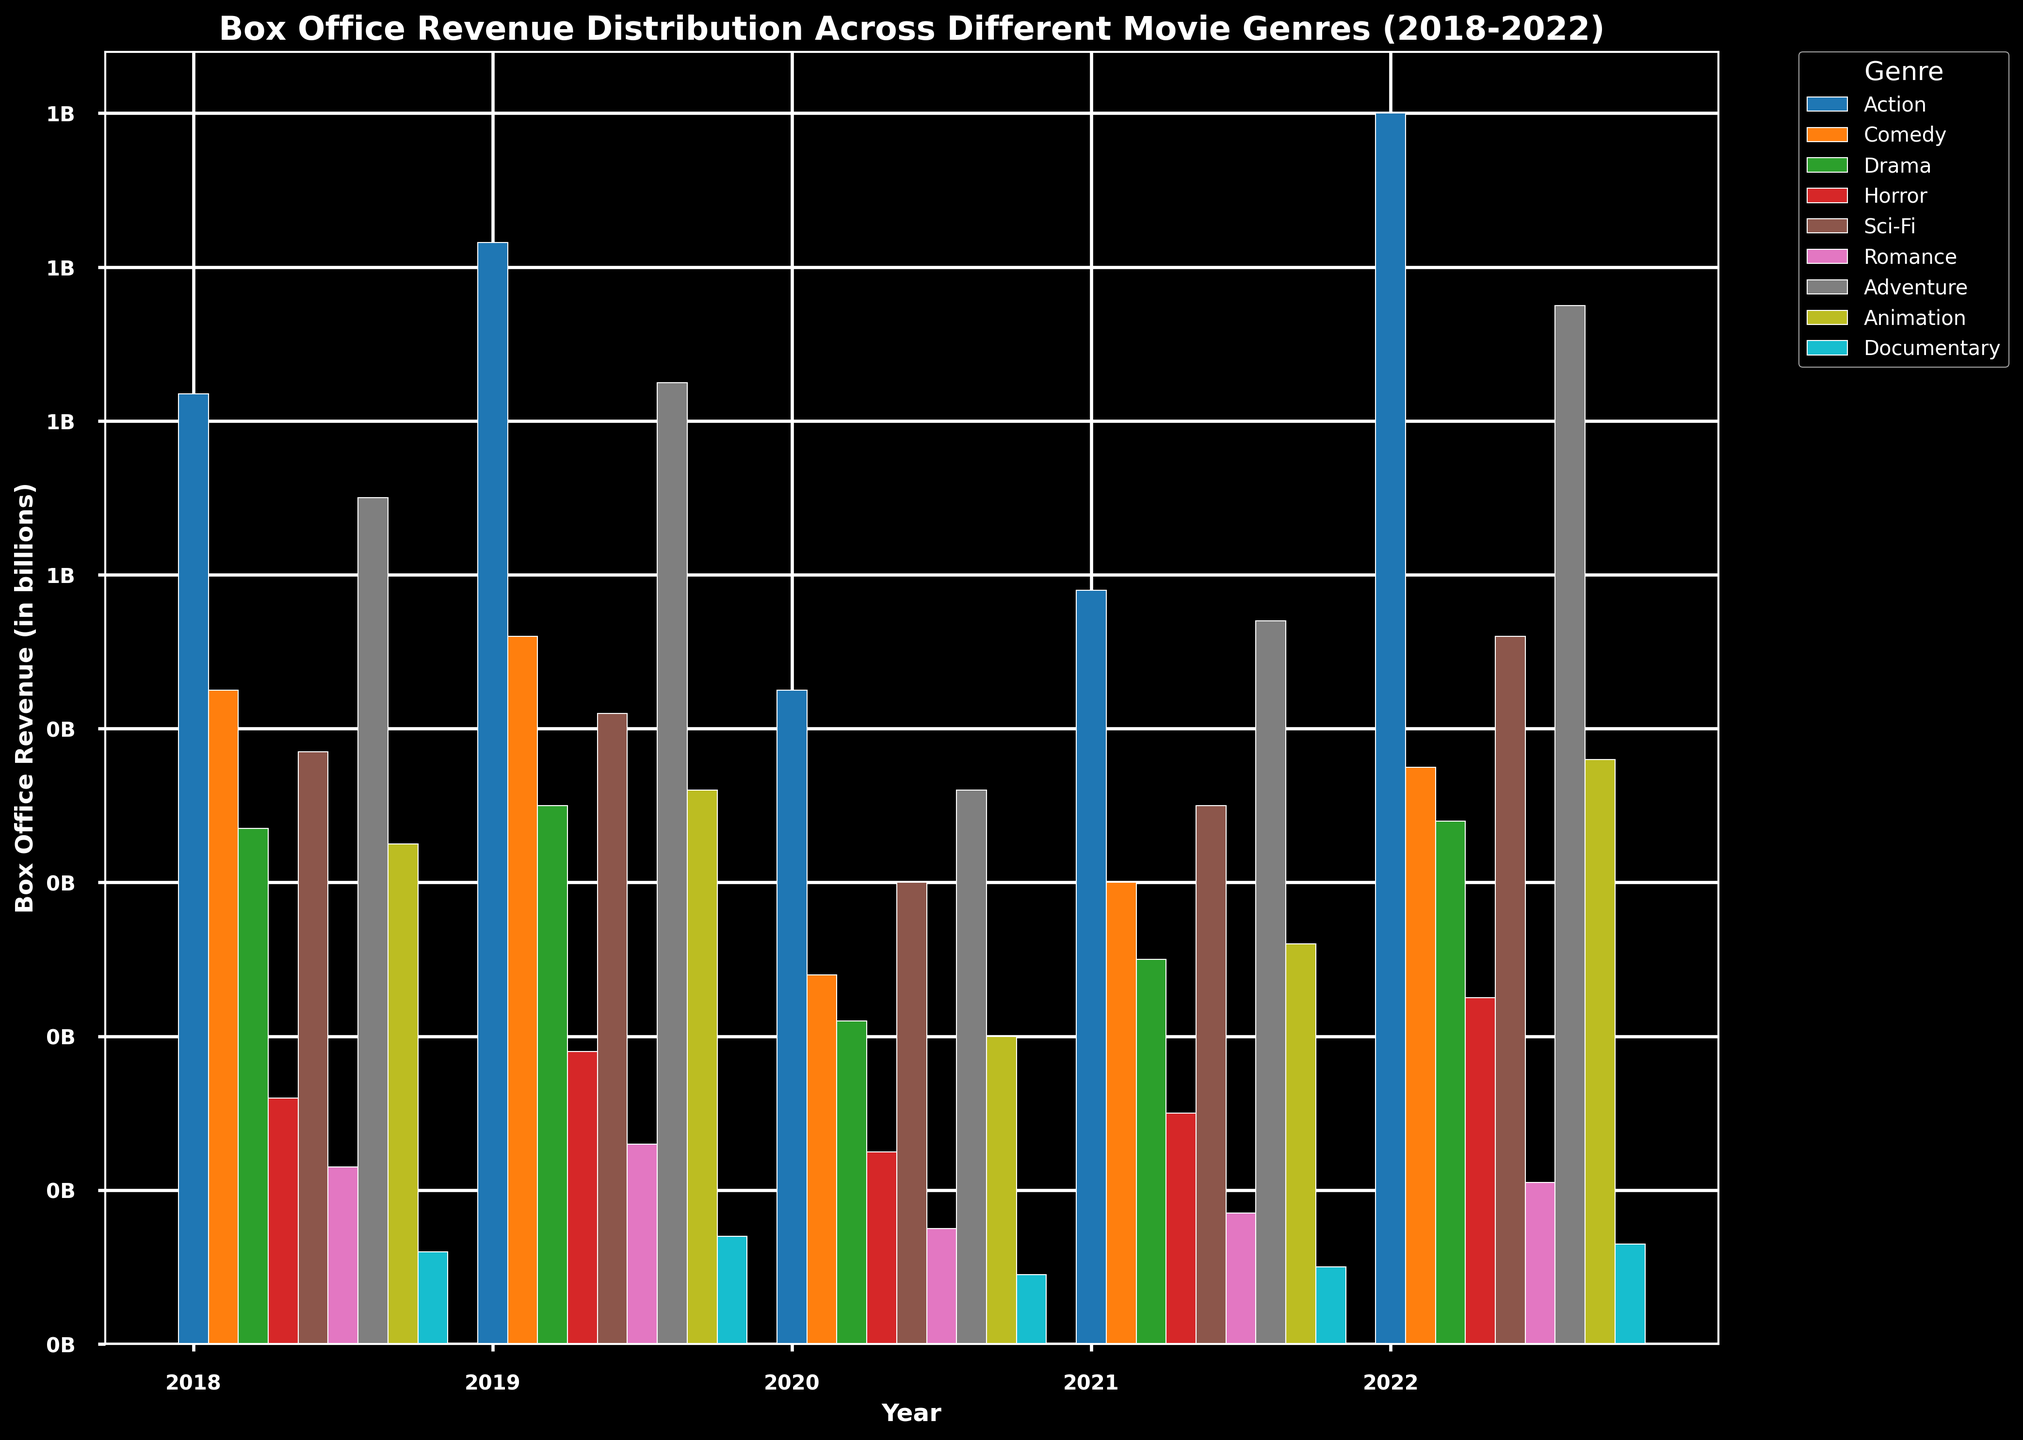Which genre had the highest box office revenue in 2022? To determine this, look at the height of each bar representing the different genres in 2022. The tallest bar will indicate the genre with the highest revenue. In this case, the tall bar for the Action genre surpasses all others.
Answer: Action How did the box office revenue for Comedy films change from 2020 to 2021? Compare the height of the Comedy bars between 2020 and 2021. The height of the comedy bar increased from 480 million in 2020 to 600 million in 2021.
Answer: Increased Which year saw the lowest box office revenue for the Documentary genre? Examine the bars representing the Documentary genre across all years. The shortest bar indicates the lowest revenue year. Here, 2020 has the shortest bar for Documentary.
Answer: 2020 What is the combined box office revenue for the Sci-Fi genre in 2019 and 2022? Find the heights (or values) of the Sci-Fi bars for 2019 and 2022, then add those values together. Sci-Fi revenue in 2019 is 820 million and in 2022 is 920 million. Their sum is 820 + 920 = 1740 million.
Answer: 1740 million Which genre shows the most consistent revenue over the 5 years? Look for the genre with the bars at almost the same height across all years, indicating consistent revenues. By comparing all genres, Drama appears to be the one with the most consistent revenue.
Answer: Drama Between Action and Adventure films, which had higher overall revenue across the given years? Sum the heights (or values) of bars representing Action across all years and do the same for Adventure. Action has values: 1235, 1432, 850, 980, 1600 million, totaling 7097 million. Adventure has values: 1100, 1250, 720, 940, 1350 million, totaling 5360 million.
Answer: Action By how much did the revenue of Animation films in 2022 exceed that of 2020? Subtract the revenue of Animation in 2020 from that in 2022. Animation revenues are 400 million in 2020 and 760 million in 2022, so 760 - 400 = 360 million.
Answer: 360 million Which year had the highest overall box office revenue across all genres? Add up the revenues from all genres for each year and compare them to find the year with the highest total. Summing each year's genre revenues and comparing would show that 2019 has the highest overall revenue.
Answer: 2019 What is the average yearly revenue for Horror films over the last 5 years? Add the yearly revenues for Horror films and then divide by the number of years. Horror revenues: 320, 380, 250, 300, 450 million, giving a total of 1700 million. The average is 1700/5 = 340 million.
Answer: 340 million Which genre's revenue dropped the most from 2019 to 2020? Identify the difference in height (or values) for each genre's bars from 2019 to 2020 and find the maximum drop. Action dropped by 1432 - 850 = 582 million, which is the highest drop among all genres.
Answer: Action 